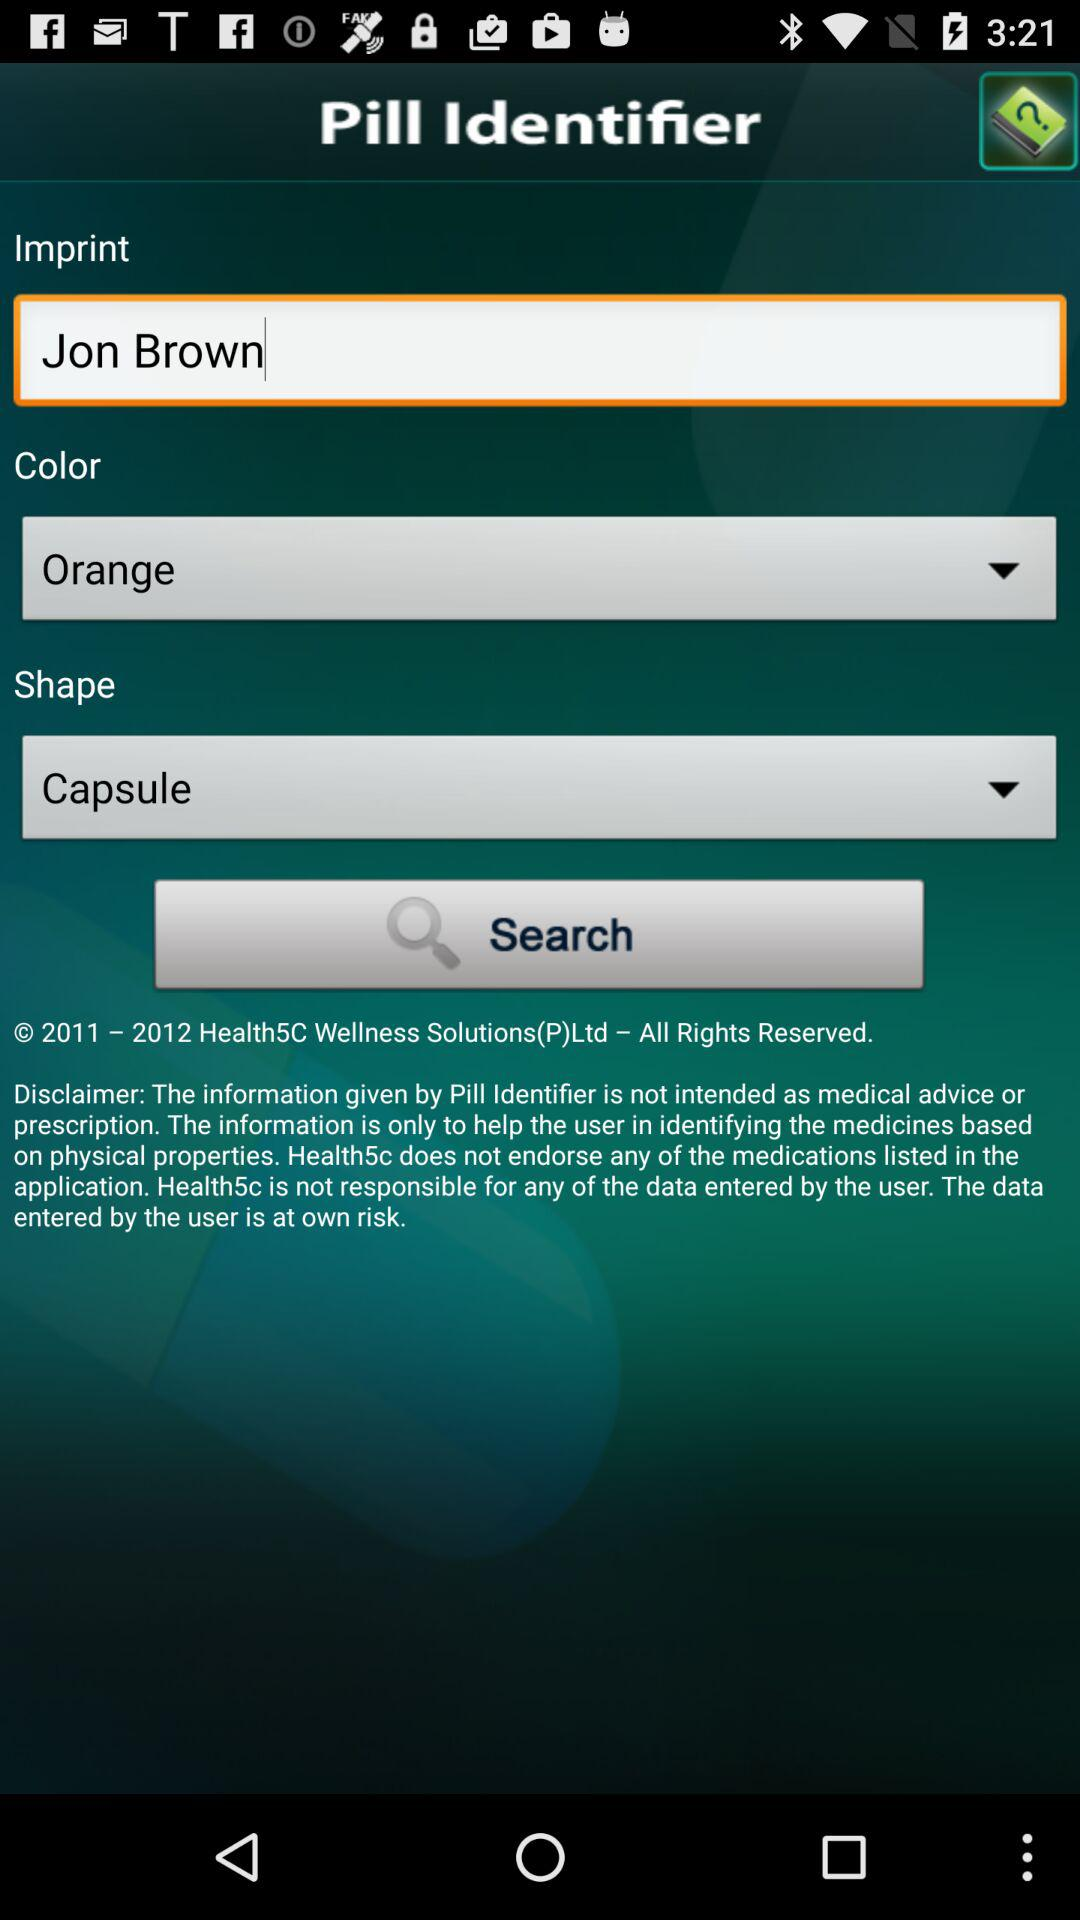What was the color of the pill? The color of the pill was orange. 